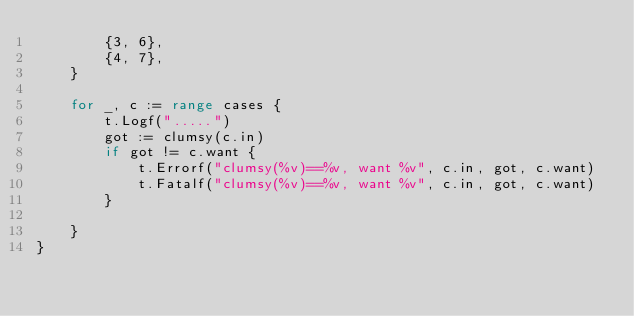<code> <loc_0><loc_0><loc_500><loc_500><_Go_>		{3, 6},
		{4, 7},
	}

	for _, c := range cases {
		t.Logf(".....")
		got := clumsy(c.in)
		if got != c.want {
			t.Errorf("clumsy(%v)==%v, want %v", c.in, got, c.want)
			t.Fatalf("clumsy(%v)==%v, want %v", c.in, got, c.want)
		}

	}
}
</code> 